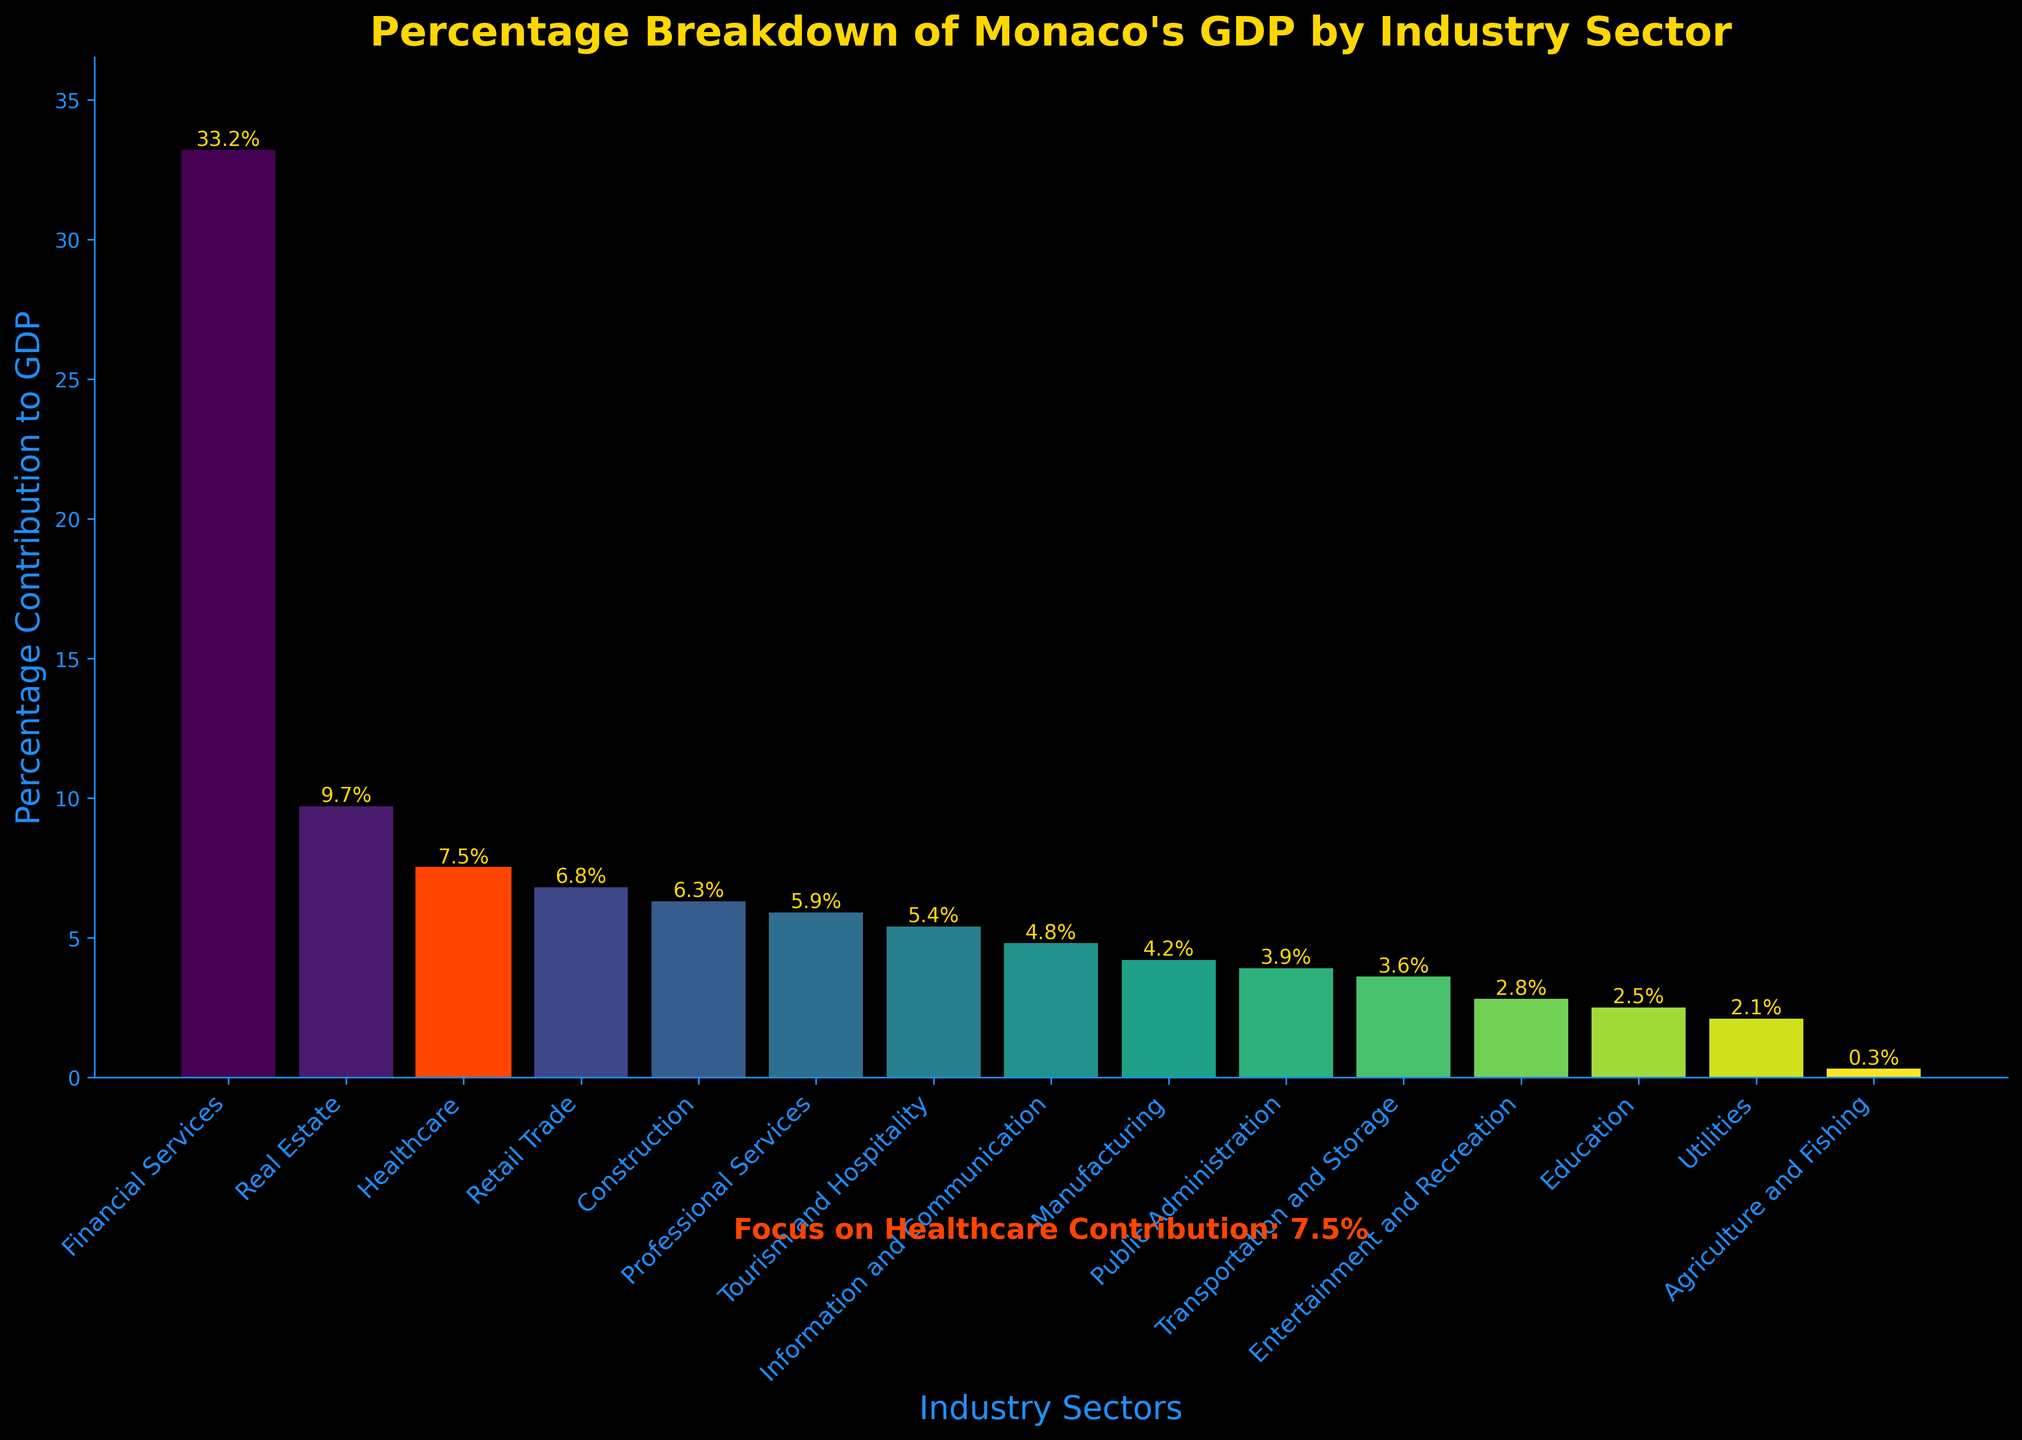What's the percentage contribution of the Healthcare sector to Monaco's GDP? The Healthcare sector's percentage contribution is shown in the figure as the value on the bar labeled "Healthcare".
Answer: 7.5% How does the Healthcare sector's contribution compare to the Financial Services sector? The bar for Financial Services is the tallest, with a contribution of 33.2%, while the Healthcare sector has a contribution of 7.5%. Financial Services contribute significantly more than Healthcare.
Answer: The Healthcare sector contributes much less than Financial Services Which sectors have a lower GDP percentage contribution than Healthcare? By comparing the heights of the bars and their corresponding values, we can see that sectors like Retail Trade, Construction, Professional Services, Tourism and Hospitality, Information and Communication, Manufacturing, Public Administration, Transportation and Storage, Entertainment and Recreation, Education, Utilities, and Agriculture and Fishing all have lower contributions than Healthcare.
Answer: Retail Trade, Construction, Professional Services, Tourism and Hospitality, Information and Communication, Manufacturing, Public Administration, Transportation and Storage, Entertainment and Recreation, Education, Utilities, and Agriculture and Fishing What is the difference in percentage contribution between Healthcare and Real Estate? The figure shows Real Estate at 9.7% and Healthcare at 7.5%. Subtracting the Healthcare percentage from Real Estate's gives the difference. 9.7% - 7.5% = 2.2%.
Answer: 2.2% If we sum the GDP contributions of the top three sectors, what is the total? The top three sectors by percentage are Financial Services (33.2%), Real Estate (9.7%), and Healthcare (7.5%). Adding these gives 33.2% + 9.7% + 7.5% = 50.4%.
Answer: 50.4% Which sector is highlighted, and why? The Healthcare sector is highlighted using a distinct color (red) to emphasize its contribution to the GDP. This is noted by the text annotation focusing on Healthcare's 7.5% contribution.
Answer: Healthcare sector Find the average GDP contribution of the bottom five sectors. The bottom five sectors by percentage contribution are Public Administration (3.9%), Transportation and Storage (3.6%), Entertainment and Recreation (2.8%), Education (2.5%), and Utilities (2.1%). Summing these gives 3.9% + 3.6% + 2.8% + 2.5% + 2.1% = 14.9%. The average is 14.9% / 5 = 2.98%.
Answer: 2.98% How does the visual color differentiation help in identifying the Healthcare sector? The Healthcare sector bar is colored differently (in red), making it stand out against the other sectors that are shown in shades of green. This visual cue helps to instantly focus attention on Healthcare's contribution.
Answer: Differentiated by red color What is the combined GDP contribution of Agriculture and Fishing, and Manufacturing? The Agriculture and Fishing sector contributes 0.3%, and Manufacturing contributes 4.2%. Adding these gives 0.3% + 4.2% = 4.5%.
Answer: 4.5% Which sector has the closest GDP percentage contribution to Healthcare? Looking at the bars and their values, we see that Retail Trade has a percentage contribution of 6.8%, which is closest to Healthcare's 7.5%.
Answer: Retail Trade 